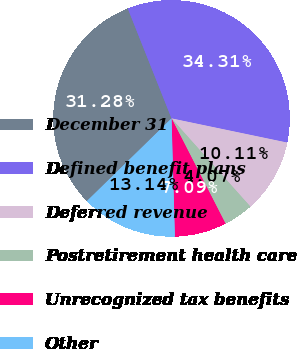Convert chart. <chart><loc_0><loc_0><loc_500><loc_500><pie_chart><fcel>December 31<fcel>Defined benefit plans<fcel>Deferred revenue<fcel>Postretirement health care<fcel>Unrecognized tax benefits<fcel>Other<nl><fcel>31.28%<fcel>34.31%<fcel>10.11%<fcel>4.07%<fcel>7.09%<fcel>13.14%<nl></chart> 